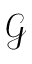Convert formula to latex. <formula><loc_0><loc_0><loc_500><loc_500>\mathcal { G }</formula> 